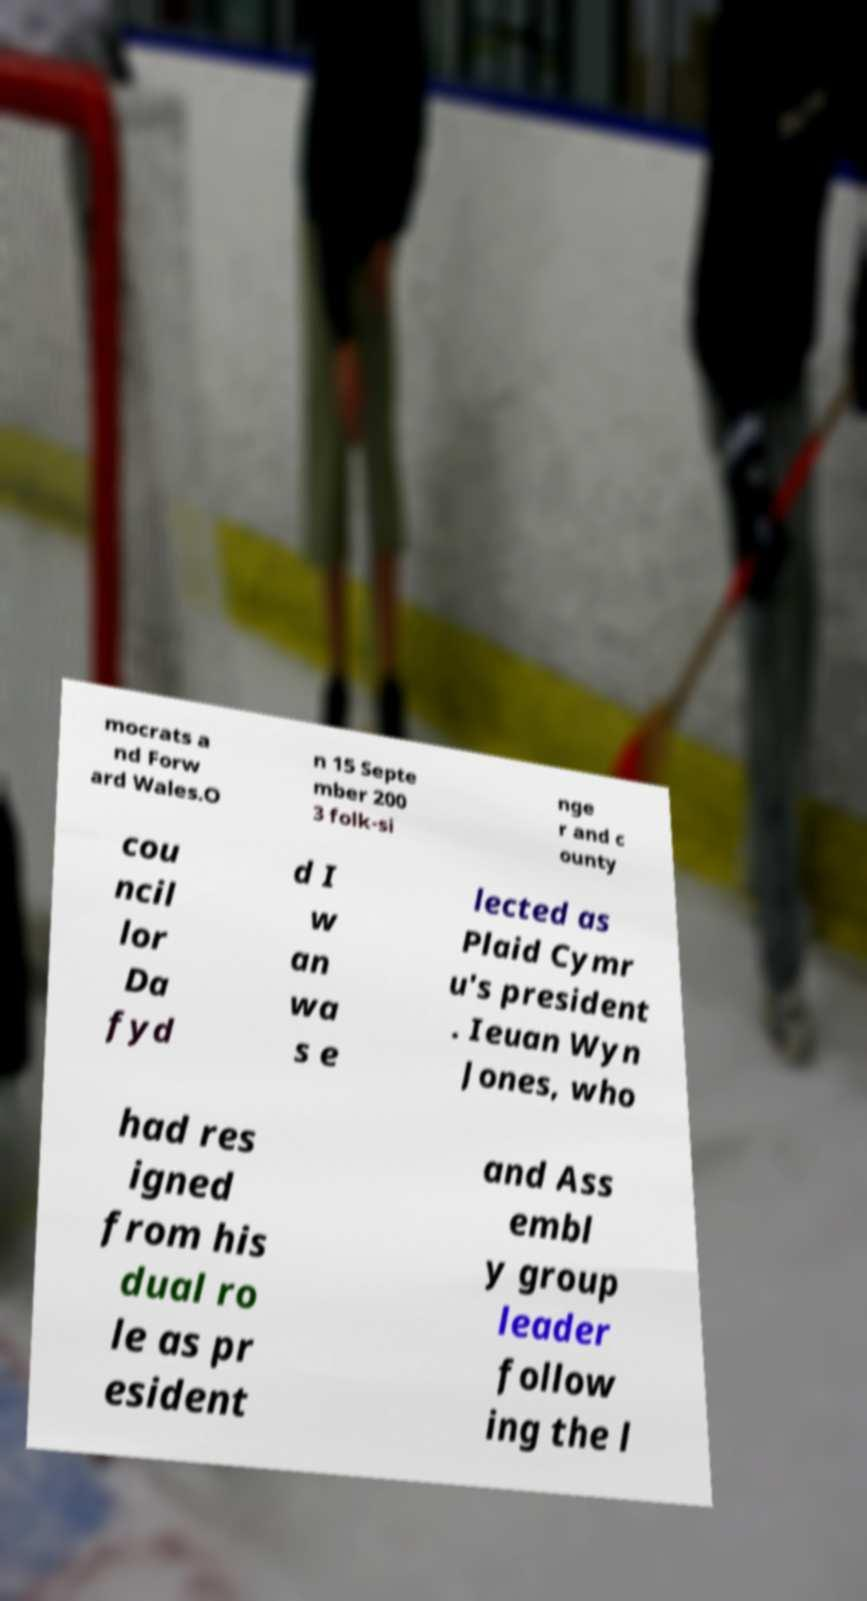Can you read and provide the text displayed in the image?This photo seems to have some interesting text. Can you extract and type it out for me? mocrats a nd Forw ard Wales.O n 15 Septe mber 200 3 folk-si nge r and c ounty cou ncil lor Da fyd d I w an wa s e lected as Plaid Cymr u's president . Ieuan Wyn Jones, who had res igned from his dual ro le as pr esident and Ass embl y group leader follow ing the l 